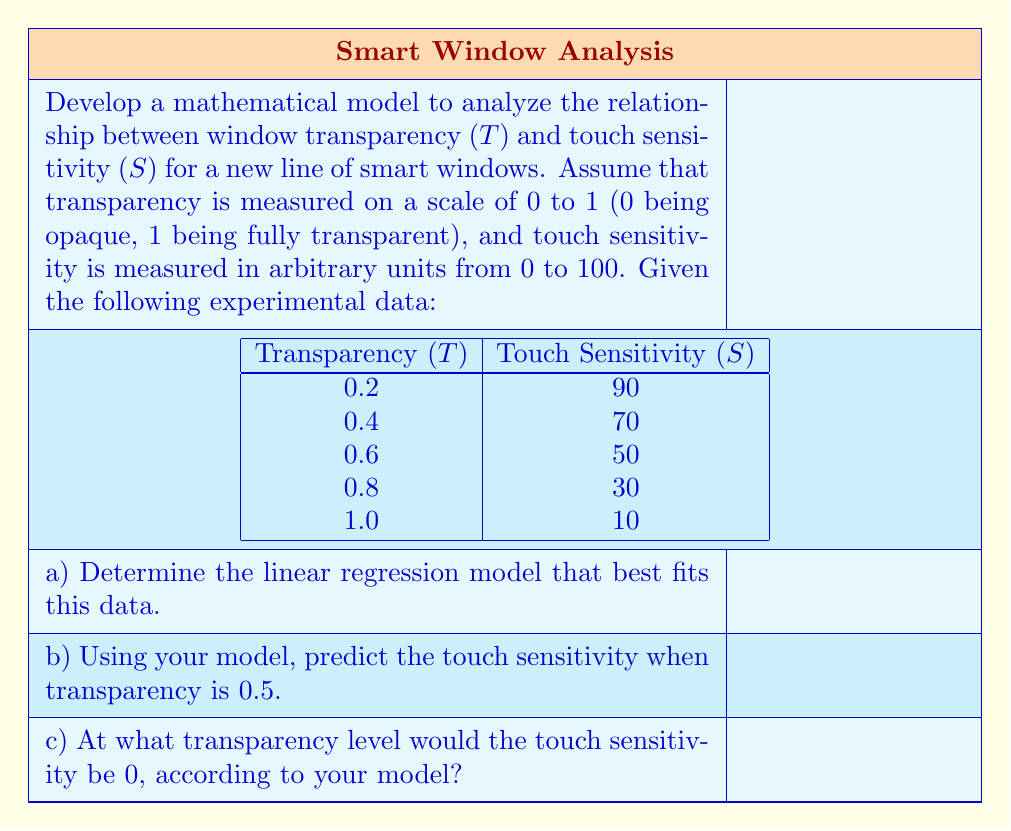Can you answer this question? To solve this problem, we'll use linear regression to model the relationship between transparency ($T$) and touch sensitivity ($S$).

a) Linear regression model:

We'll use the formula $S = mT + b$, where $m$ is the slope and $b$ is the y-intercept.

To find $m$ and $b$, we'll use the following formulas:

$$m = \frac{n\sum(TiSi) - \sum Ti \sum Si}{n\sum Ti^2 - (\sum Ti)^2}$$

$$b = \bar{S} - m\bar{T}$$

Where $n$ is the number of data points, $\bar{T}$ is the mean of $T$ values, and $\bar{S}$ is the mean of $S$ values.

Calculations:
$n = 5$
$\sum Ti = 3$
$\sum Si = 250$
$\sum(TiSi) = 122$
$\sum Ti^2 = 2.2$
$\bar{T} = 0.6$
$\bar{S} = 50$

Plugging these values into the formulas:

$$m = \frac{5(122) - 3(250)}{5(2.2) - 3^2} = -100$$

$$b = 50 - (-100)(0.6) = 110$$

Therefore, our linear regression model is:

$$S = -100T + 110$$

b) Predicting touch sensitivity when transparency is 0.5:

Plug $T = 0.5$ into our model:

$$S = -100(0.5) + 110 = 60$$

c) Transparency level when touch sensitivity is 0:

Set $S = 0$ and solve for $T$:

$$0 = -100T + 110$$
$$100T = 110$$
$$T = 1.1$$

However, since transparency is defined on a scale of 0 to 1, the maximum possible value is 1.0.
Answer: a) The linear regression model is $S = -100T + 110$
b) When transparency is 0.5, the predicted touch sensitivity is 60
c) According to the model, touch sensitivity would reach 0 at a transparency of 1.1, but since transparency is limited to a maximum of 1.0, the model predicts that touch sensitivity will not reach 0 within the defined transparency range. 